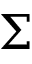Convert formula to latex. <formula><loc_0><loc_0><loc_500><loc_500>\Sigma</formula> 